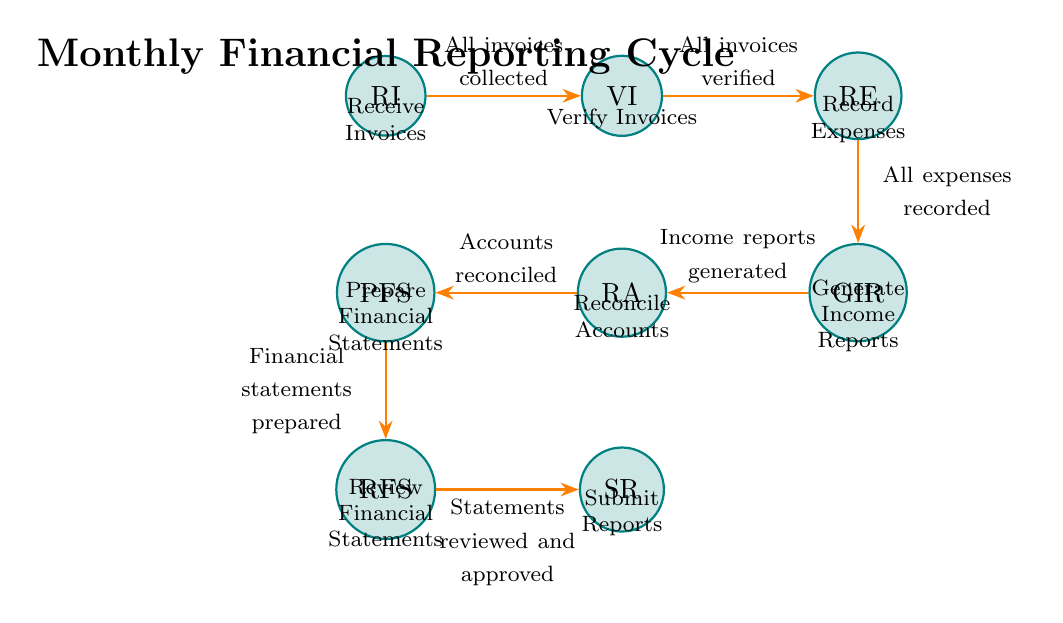What is the first state in the cycle? The diagram lists the states in the order of the monthly financial reporting cycle, starting with "Receive Invoices" as the first state.
Answer: Receive Invoices How many states are there in the diagram? By counting the states listed in the diagram, there are a total of eight states present in the monthly financial reporting cycle.
Answer: Eight What happens after verifying invoices? Following the "Verify Invoices" state, if all invoices are verified, the process transitions to the next state, which is "Record Expenses."
Answer: Record Expenses Which state comes before preparing financial statements? In the flow of the diagram, the state that occurs immediately before "Prepare Financial Statements" is "Reconcile Accounts."
Answer: Reconcile Accounts What is the condition for moving to the state of generating income reports? The transition from "Record Expenses" to "Generate Income Reports" occurs when all expenses are recorded according to the condition stated in the diagram.
Answer: All expenses recorded What is the last state in this financial reporting cycle? The process concludes at the "Submit Reports" state, as it is the final step in the monthly financial reporting cycle.
Answer: Submit Reports How many transitions are there in total? Each transition between the states is clearly defined in the diagram, and there are a total of seven transitions between the eight states.
Answer: Seven What condition must be met to review financial statements? The condition for moving from "Prepare Financial Statements" to "Review Financial Statements" is that financial statements must be prepared, as indicated in the diagram.
Answer: Financial statements prepared What is the state directly after generating income reports? The state that directly follows "Generate Income Reports" in the flow is "Reconcile Accounts," as per the transitions outlined in the diagram.
Answer: Reconcile Accounts 